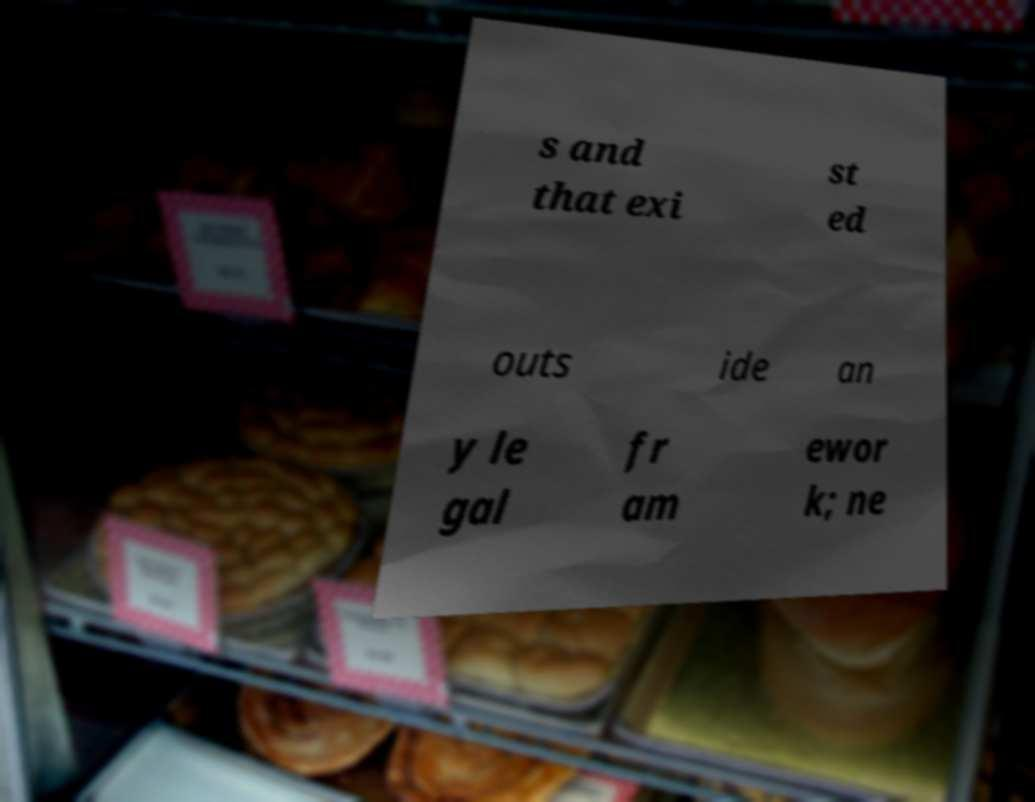I need the written content from this picture converted into text. Can you do that? s and that exi st ed outs ide an y le gal fr am ewor k; ne 